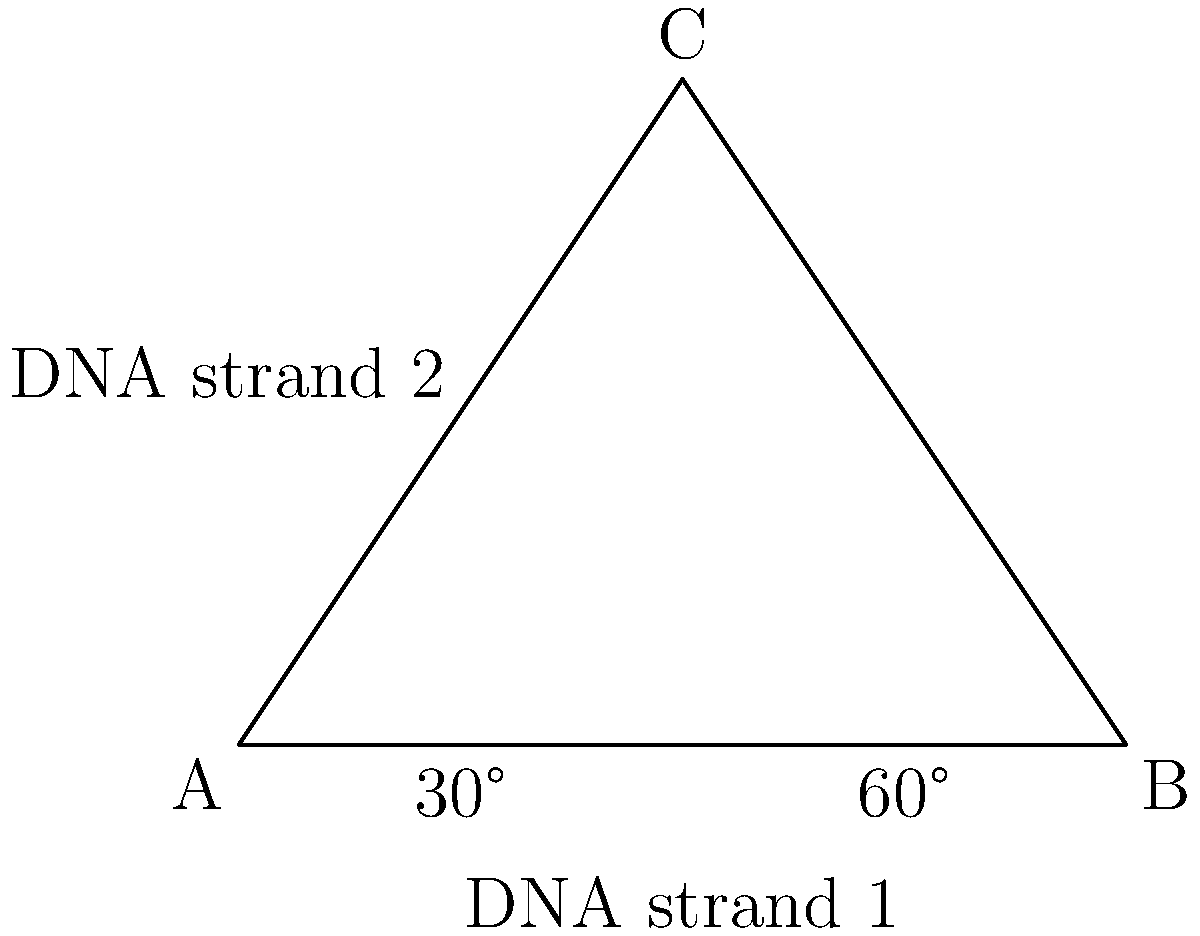In a genetic study, two DNA strands are represented as intersecting lines in a plane. The angle between these strands is crucial for understanding their interaction. Given that the angle between DNA strand 1 and the horizontal axis is 30°, and the angle between DNA strand 2 and the horizontal axis is 60°, what is the angle between the two DNA strands? To find the angle between the two DNA strands, we can follow these steps:

1. Recognize that the two DNA strands are represented by the lines AB and AC in the triangle ABC.

2. The angle between DNA strand 1 and the horizontal axis is given as 30°.

3. The angle between DNA strand 2 and the horizontal axis is given as 60°.

4. To find the angle between the two strands, we need to subtract the smaller angle from the larger angle:

   $$\text{Angle between strands} = 60° - 30° = 30°$$

5. This is because the angle between two lines is equal to the absolute difference between their angles with respect to a common reference line (in this case, the horizontal axis).

Therefore, the angle between the two DNA strands is 30°.
Answer: 30° 